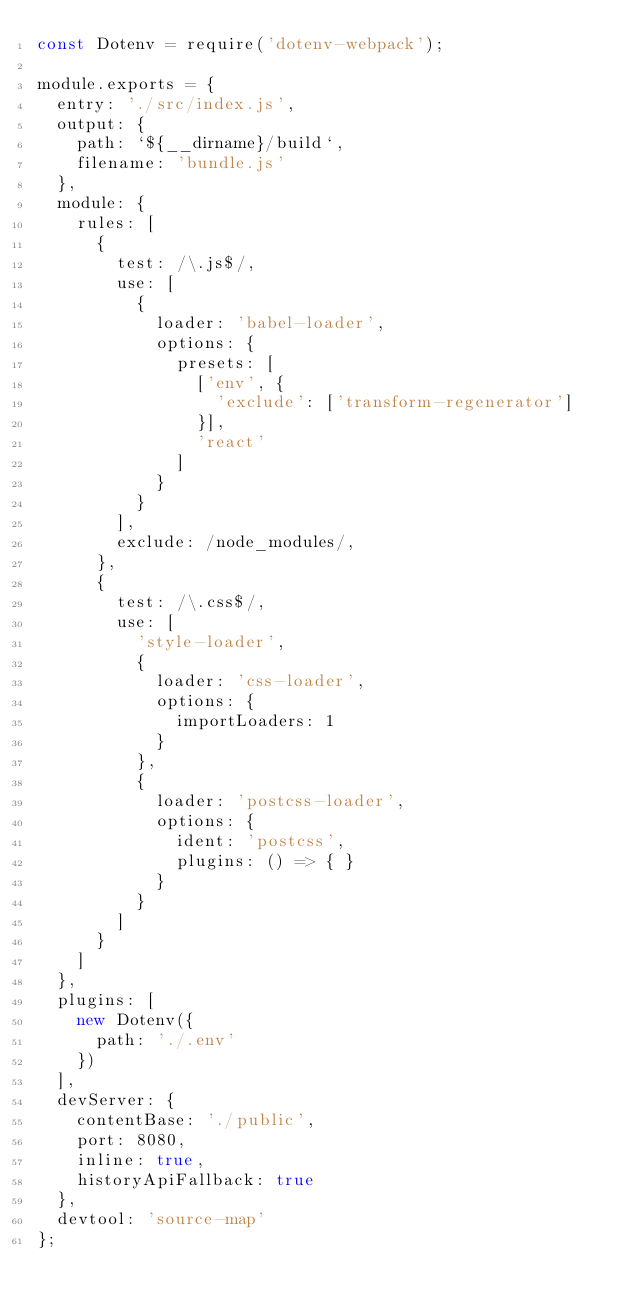<code> <loc_0><loc_0><loc_500><loc_500><_JavaScript_>const Dotenv = require('dotenv-webpack');

module.exports = {
  entry: './src/index.js',
  output: {
    path: `${__dirname}/build`,
    filename: 'bundle.js'
  },
  module: {
    rules: [
      {
        test: /\.js$/,
        use: [
          {
            loader: 'babel-loader',
            options: {
              presets: [
                ['env', {
                  'exclude': ['transform-regenerator']
                }],
                'react'
              ]
            }
          }
        ],
        exclude: /node_modules/,
      },
      {
        test: /\.css$/,
        use: [
          'style-loader',
          {
            loader: 'css-loader',
            options: {
              importLoaders: 1
            }
          },
          {
            loader: 'postcss-loader',
            options: {
              ident: 'postcss',
              plugins: () => { }
            }
          }
        ]
      }
    ]
  },
  plugins: [
    new Dotenv({
      path: './.env'
    })
  ],
  devServer: {
    contentBase: './public',
    port: 8080,
    inline: true,
    historyApiFallback: true
  },
  devtool: 'source-map'
};
</code> 